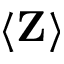Convert formula to latex. <formula><loc_0><loc_0><loc_500><loc_500>\langle Z \rangle</formula> 